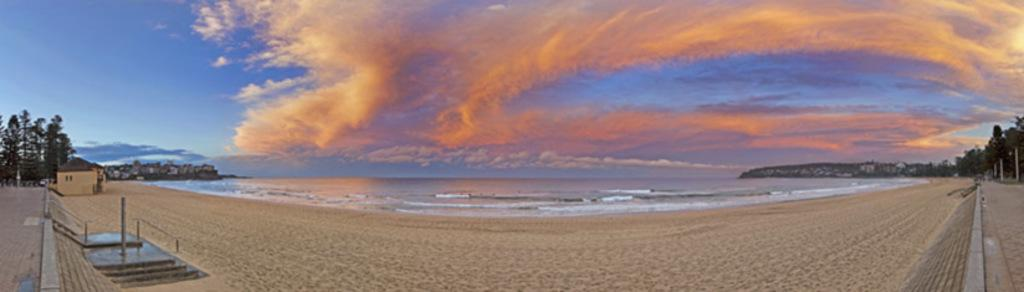What is the primary element present in the image? There is water in the image. What structures can be seen in the image? There are buildings in the image. What type of vegetation is present in the image? There are trees in the image. What can be seen in the background of the image? The sky is visible in the background of the image. What type of table is being used for teaching in the image? There is no table or teaching activity present in the image. What kind of tail can be seen on the trees in the image? There are no tails present in the image; it features trees without any tails. 